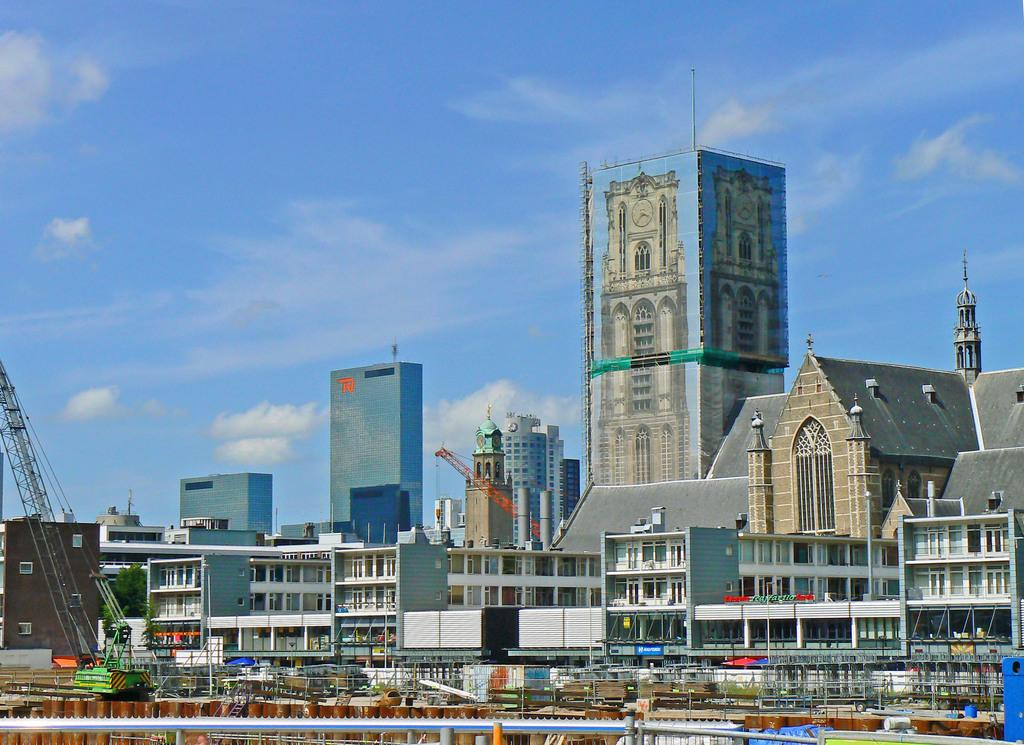What type of structures can be seen in the image? There are buildings in the image. What feature is common among the buildings? There are windows in the image. What utility pole is present in the image? There is a current pole in the image. What is visible in the background of the image? The sky is visible in the image. What can be observed in the sky? Clouds are present in the sky. What type of tree is depicted on the page in the image? There is no tree or page present in the image. What observation can be made about the behavior of the animals in the image? There are no animals present in the image. 